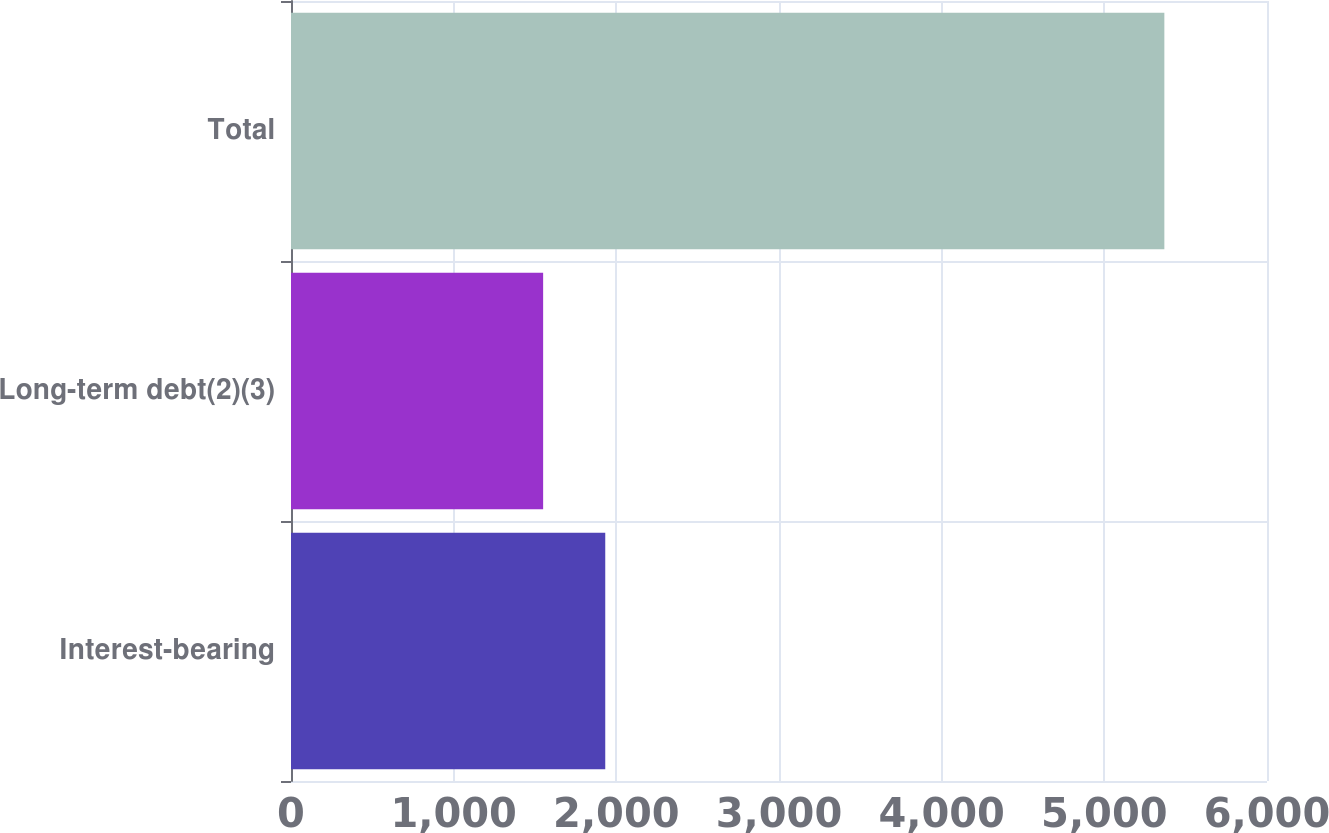Convert chart to OTSL. <chart><loc_0><loc_0><loc_500><loc_500><bar_chart><fcel>Interest-bearing<fcel>Long-term debt(2)(3)<fcel>Total<nl><fcel>1931.9<fcel>1550<fcel>5369<nl></chart> 